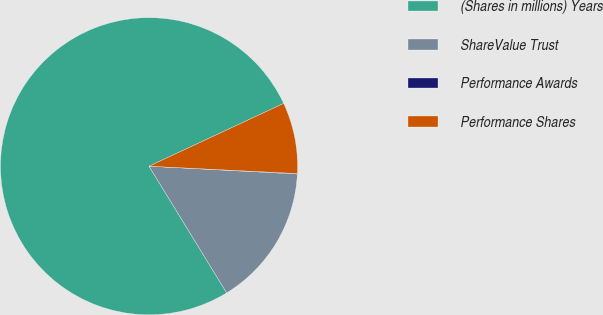Convert chart. <chart><loc_0><loc_0><loc_500><loc_500><pie_chart><fcel>(Shares in millions) Years<fcel>ShareValue Trust<fcel>Performance Awards<fcel>Performance Shares<nl><fcel>76.81%<fcel>15.41%<fcel>0.05%<fcel>7.73%<nl></chart> 